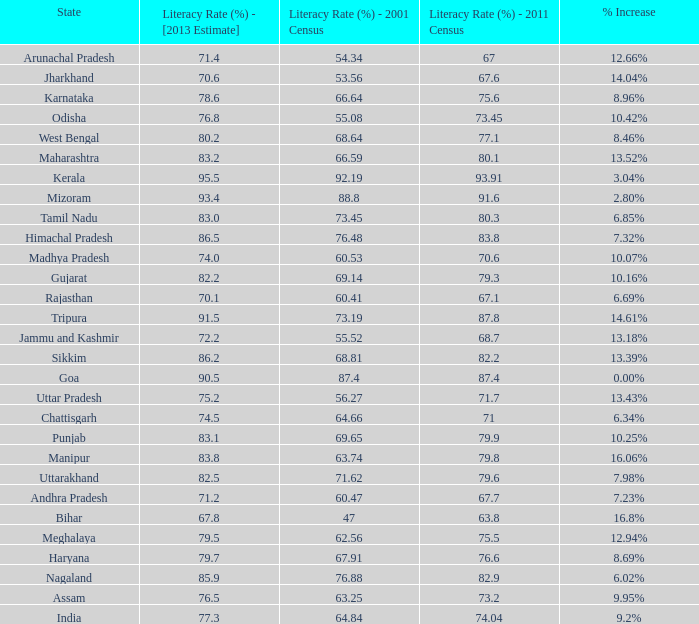What is the average increase in literacy for the states that had a rate higher than 73.2% in 2011, less than 68.81% in 2001, and an estimate of 76.8% for 2013? 10.42%. 